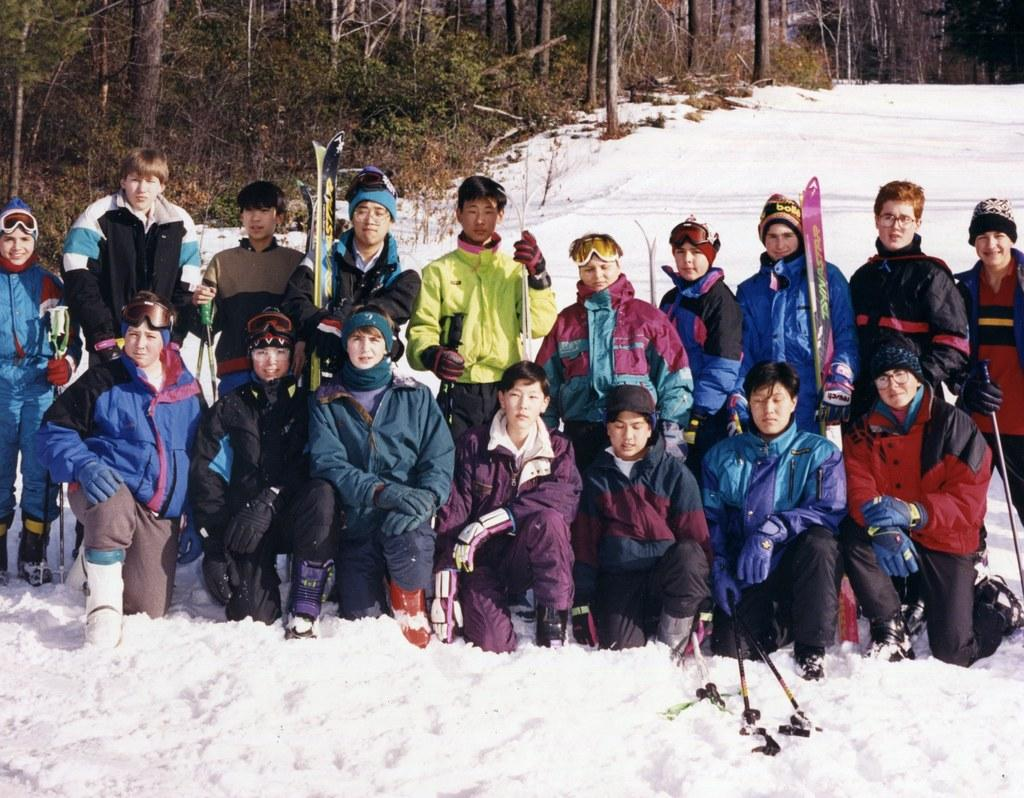How many people are in the image? There is a group of people in the image, but the exact number is not specified. What are some people doing in the image? Some people are holding objects in their hands. What is the weather like in the image? There is snow visible in the image, indicating a cold and likely wintery scene. What type of natural environment is depicted in the image? There are many trees in the image, suggesting a forest or wooded area. What color is the hair of the person laughing in the image? There is no person laughing in the image, and no information about hair color is provided. 